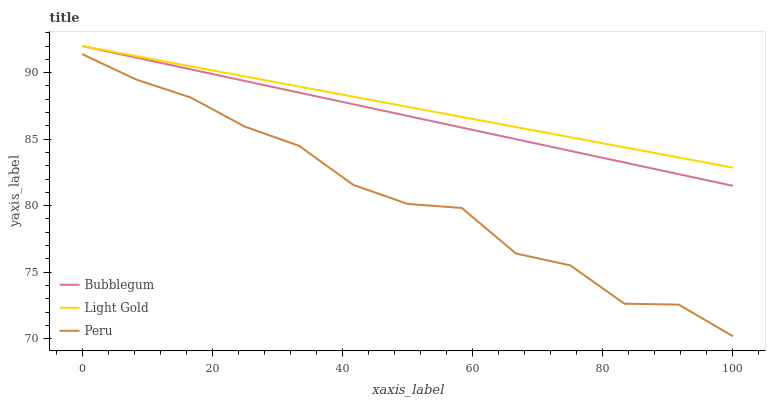Does Peru have the minimum area under the curve?
Answer yes or no. Yes. Does Light Gold have the maximum area under the curve?
Answer yes or no. Yes. Does Bubblegum have the minimum area under the curve?
Answer yes or no. No. Does Bubblegum have the maximum area under the curve?
Answer yes or no. No. Is Bubblegum the smoothest?
Answer yes or no. Yes. Is Peru the roughest?
Answer yes or no. Yes. Is Peru the smoothest?
Answer yes or no. No. Is Bubblegum the roughest?
Answer yes or no. No. Does Peru have the lowest value?
Answer yes or no. Yes. Does Bubblegum have the lowest value?
Answer yes or no. No. Does Bubblegum have the highest value?
Answer yes or no. Yes. Does Peru have the highest value?
Answer yes or no. No. Is Peru less than Light Gold?
Answer yes or no. Yes. Is Light Gold greater than Peru?
Answer yes or no. Yes. Does Bubblegum intersect Light Gold?
Answer yes or no. Yes. Is Bubblegum less than Light Gold?
Answer yes or no. No. Is Bubblegum greater than Light Gold?
Answer yes or no. No. Does Peru intersect Light Gold?
Answer yes or no. No. 